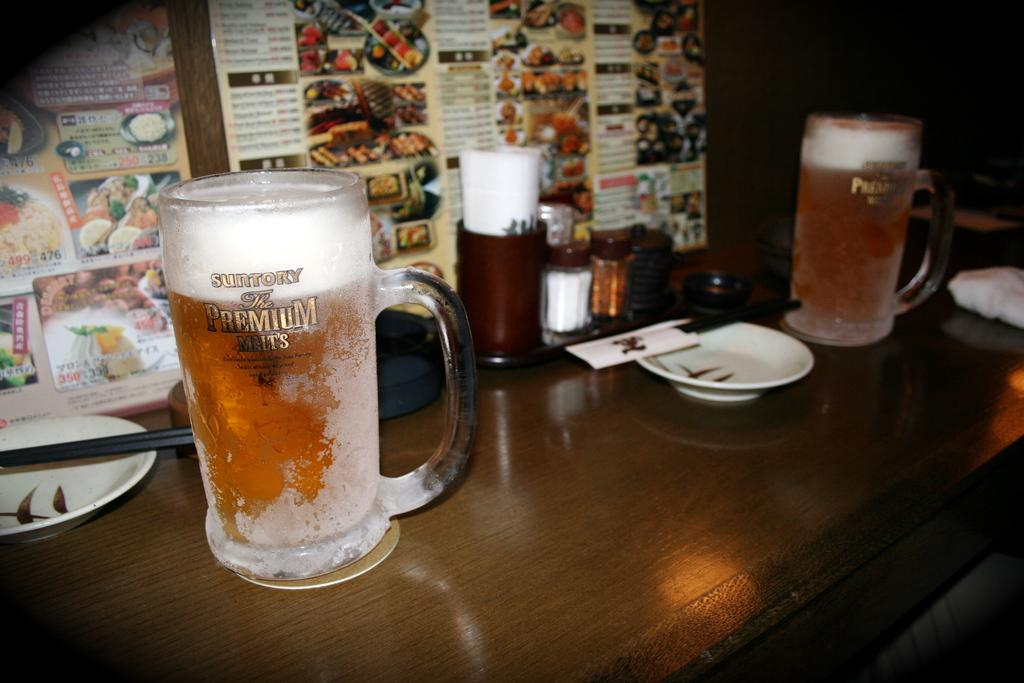<image>
Present a compact description of the photo's key features. Two mugs of Suntory premium malt sitting on a wooden table. 